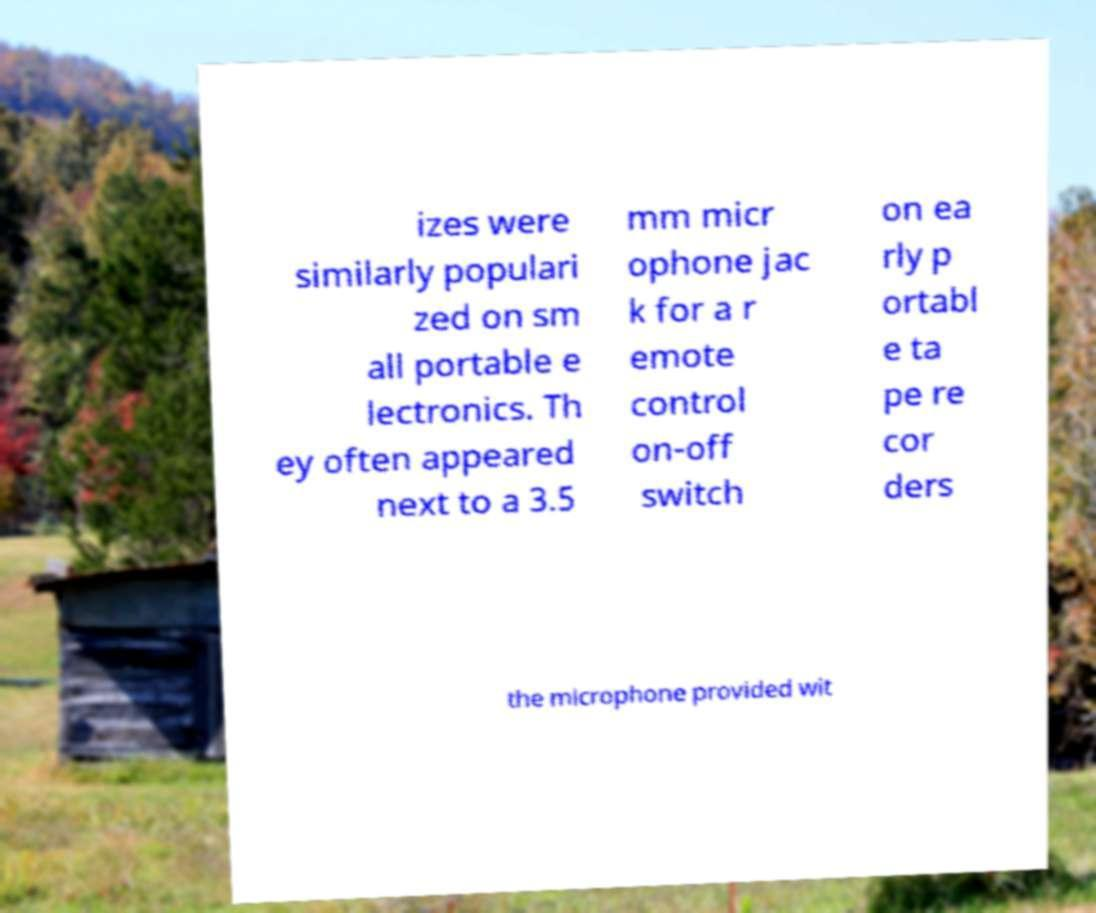Could you assist in decoding the text presented in this image and type it out clearly? izes were similarly populari zed on sm all portable e lectronics. Th ey often appeared next to a 3.5 mm micr ophone jac k for a r emote control on-off switch on ea rly p ortabl e ta pe re cor ders the microphone provided wit 